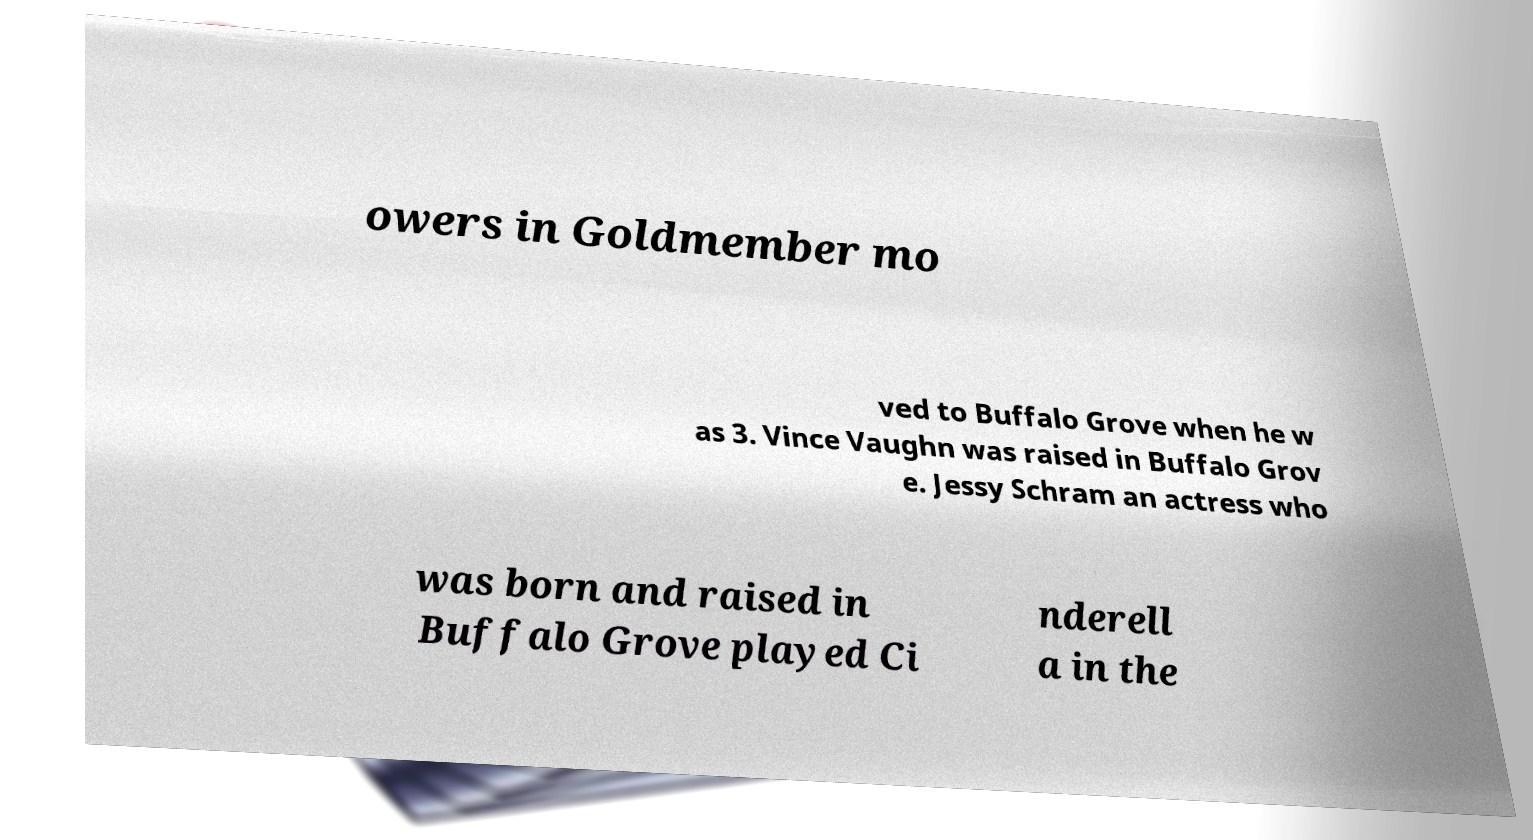Could you assist in decoding the text presented in this image and type it out clearly? owers in Goldmember mo ved to Buffalo Grove when he w as 3. Vince Vaughn was raised in Buffalo Grov e. Jessy Schram an actress who was born and raised in Buffalo Grove played Ci nderell a in the 